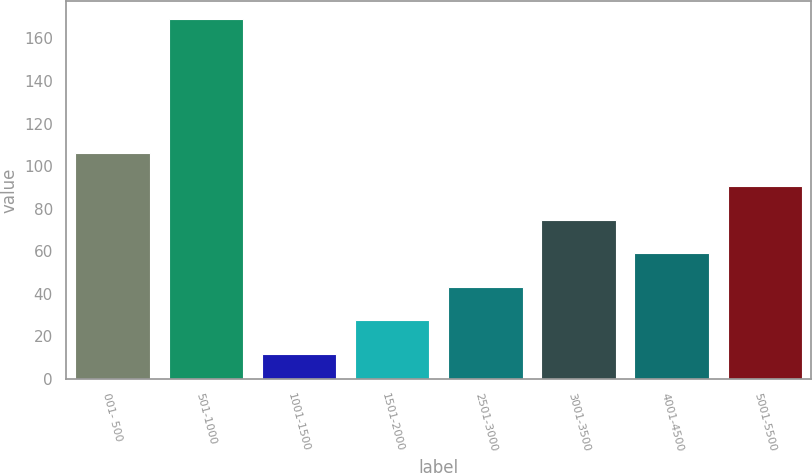Convert chart to OTSL. <chart><loc_0><loc_0><loc_500><loc_500><bar_chart><fcel>001- 500<fcel>501-1000<fcel>1001-1500<fcel>1501-2000<fcel>2501-3000<fcel>3001-3500<fcel>4001-4500<fcel>5001-5500<nl><fcel>106.2<fcel>169<fcel>12<fcel>27.7<fcel>43.4<fcel>74.8<fcel>59.1<fcel>90.5<nl></chart> 